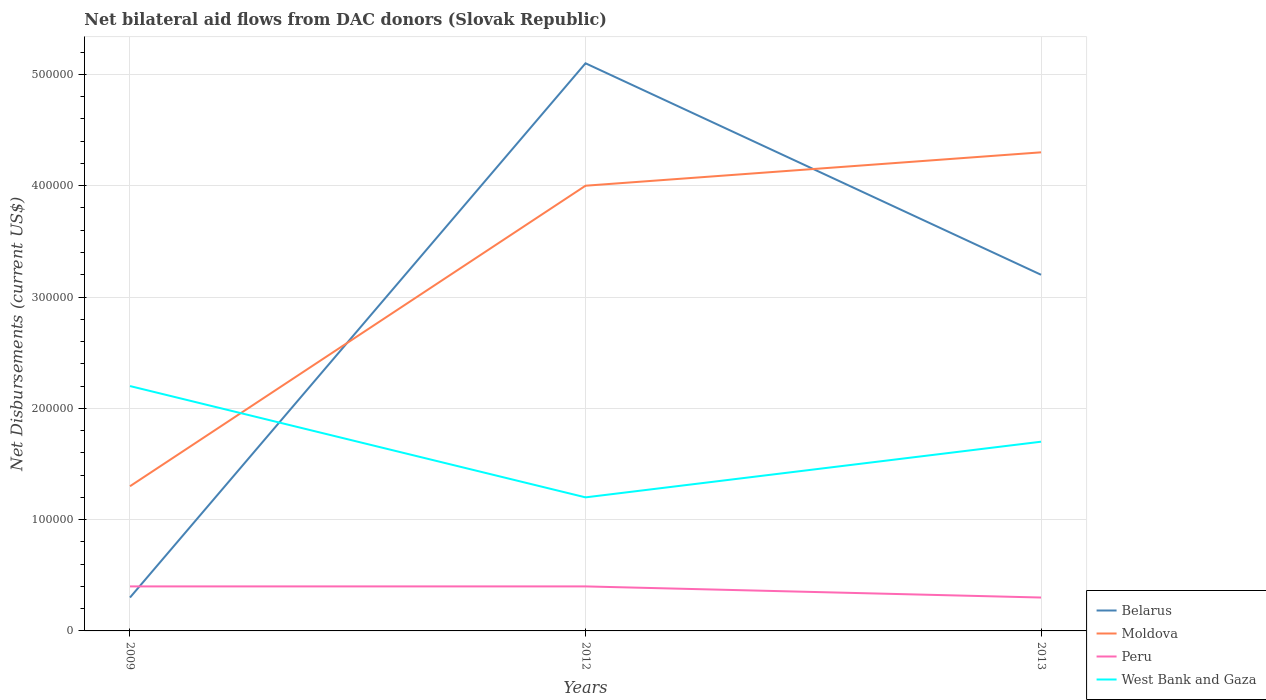How many different coloured lines are there?
Keep it short and to the point. 4. Across all years, what is the maximum net bilateral aid flows in Belarus?
Give a very brief answer. 3.00e+04. In which year was the net bilateral aid flows in Belarus maximum?
Provide a succinct answer. 2009. What is the total net bilateral aid flows in Peru in the graph?
Keep it short and to the point. 10000. What is the difference between the highest and the second highest net bilateral aid flows in West Bank and Gaza?
Provide a short and direct response. 1.00e+05. What is the difference between the highest and the lowest net bilateral aid flows in Belarus?
Give a very brief answer. 2. Is the net bilateral aid flows in Peru strictly greater than the net bilateral aid flows in Belarus over the years?
Your answer should be compact. No. How many years are there in the graph?
Offer a very short reply. 3. Does the graph contain any zero values?
Your answer should be compact. No. Does the graph contain grids?
Provide a succinct answer. Yes. Where does the legend appear in the graph?
Your response must be concise. Bottom right. How are the legend labels stacked?
Give a very brief answer. Vertical. What is the title of the graph?
Provide a short and direct response. Net bilateral aid flows from DAC donors (Slovak Republic). What is the label or title of the Y-axis?
Offer a terse response. Net Disbursements (current US$). What is the Net Disbursements (current US$) in Moldova in 2009?
Your response must be concise. 1.30e+05. What is the Net Disbursements (current US$) in Peru in 2009?
Your answer should be very brief. 4.00e+04. What is the Net Disbursements (current US$) of Belarus in 2012?
Make the answer very short. 5.10e+05. What is the Net Disbursements (current US$) in Peru in 2012?
Provide a short and direct response. 4.00e+04. What is the Net Disbursements (current US$) in Belarus in 2013?
Your response must be concise. 3.20e+05. Across all years, what is the maximum Net Disbursements (current US$) of Belarus?
Offer a terse response. 5.10e+05. Across all years, what is the maximum Net Disbursements (current US$) in Peru?
Keep it short and to the point. 4.00e+04. Across all years, what is the minimum Net Disbursements (current US$) in Moldova?
Offer a terse response. 1.30e+05. What is the total Net Disbursements (current US$) in Belarus in the graph?
Make the answer very short. 8.60e+05. What is the total Net Disbursements (current US$) in Moldova in the graph?
Your answer should be compact. 9.60e+05. What is the total Net Disbursements (current US$) in Peru in the graph?
Make the answer very short. 1.10e+05. What is the total Net Disbursements (current US$) of West Bank and Gaza in the graph?
Provide a succinct answer. 5.10e+05. What is the difference between the Net Disbursements (current US$) in Belarus in 2009 and that in 2012?
Your answer should be compact. -4.80e+05. What is the difference between the Net Disbursements (current US$) of Moldova in 2009 and that in 2012?
Give a very brief answer. -2.70e+05. What is the difference between the Net Disbursements (current US$) in Peru in 2009 and that in 2012?
Your answer should be compact. 0. What is the difference between the Net Disbursements (current US$) of Belarus in 2009 and that in 2013?
Provide a short and direct response. -2.90e+05. What is the difference between the Net Disbursements (current US$) in Moldova in 2009 and that in 2013?
Keep it short and to the point. -3.00e+05. What is the difference between the Net Disbursements (current US$) in Belarus in 2012 and that in 2013?
Your answer should be very brief. 1.90e+05. What is the difference between the Net Disbursements (current US$) of Belarus in 2009 and the Net Disbursements (current US$) of Moldova in 2012?
Your answer should be compact. -3.70e+05. What is the difference between the Net Disbursements (current US$) of Moldova in 2009 and the Net Disbursements (current US$) of Peru in 2012?
Your answer should be compact. 9.00e+04. What is the difference between the Net Disbursements (current US$) in Moldova in 2009 and the Net Disbursements (current US$) in West Bank and Gaza in 2012?
Give a very brief answer. 10000. What is the difference between the Net Disbursements (current US$) in Peru in 2009 and the Net Disbursements (current US$) in West Bank and Gaza in 2012?
Give a very brief answer. -8.00e+04. What is the difference between the Net Disbursements (current US$) of Belarus in 2009 and the Net Disbursements (current US$) of Moldova in 2013?
Your response must be concise. -4.00e+05. What is the difference between the Net Disbursements (current US$) of Belarus in 2009 and the Net Disbursements (current US$) of West Bank and Gaza in 2013?
Your response must be concise. -1.40e+05. What is the difference between the Net Disbursements (current US$) of Belarus in 2012 and the Net Disbursements (current US$) of Moldova in 2013?
Offer a very short reply. 8.00e+04. What is the difference between the Net Disbursements (current US$) of Belarus in 2012 and the Net Disbursements (current US$) of West Bank and Gaza in 2013?
Offer a terse response. 3.40e+05. What is the difference between the Net Disbursements (current US$) in Moldova in 2012 and the Net Disbursements (current US$) in Peru in 2013?
Give a very brief answer. 3.70e+05. What is the difference between the Net Disbursements (current US$) in Moldova in 2012 and the Net Disbursements (current US$) in West Bank and Gaza in 2013?
Ensure brevity in your answer.  2.30e+05. What is the average Net Disbursements (current US$) in Belarus per year?
Provide a short and direct response. 2.87e+05. What is the average Net Disbursements (current US$) in Peru per year?
Ensure brevity in your answer.  3.67e+04. In the year 2009, what is the difference between the Net Disbursements (current US$) of Belarus and Net Disbursements (current US$) of Peru?
Keep it short and to the point. -10000. In the year 2009, what is the difference between the Net Disbursements (current US$) of Belarus and Net Disbursements (current US$) of West Bank and Gaza?
Your answer should be compact. -1.90e+05. In the year 2009, what is the difference between the Net Disbursements (current US$) of Moldova and Net Disbursements (current US$) of Peru?
Ensure brevity in your answer.  9.00e+04. In the year 2012, what is the difference between the Net Disbursements (current US$) in Belarus and Net Disbursements (current US$) in Moldova?
Give a very brief answer. 1.10e+05. In the year 2012, what is the difference between the Net Disbursements (current US$) of Belarus and Net Disbursements (current US$) of Peru?
Your response must be concise. 4.70e+05. In the year 2012, what is the difference between the Net Disbursements (current US$) of Belarus and Net Disbursements (current US$) of West Bank and Gaza?
Keep it short and to the point. 3.90e+05. In the year 2013, what is the difference between the Net Disbursements (current US$) in Belarus and Net Disbursements (current US$) in Peru?
Offer a terse response. 2.90e+05. In the year 2013, what is the difference between the Net Disbursements (current US$) of Peru and Net Disbursements (current US$) of West Bank and Gaza?
Offer a very short reply. -1.40e+05. What is the ratio of the Net Disbursements (current US$) in Belarus in 2009 to that in 2012?
Offer a very short reply. 0.06. What is the ratio of the Net Disbursements (current US$) of Moldova in 2009 to that in 2012?
Make the answer very short. 0.33. What is the ratio of the Net Disbursements (current US$) in West Bank and Gaza in 2009 to that in 2012?
Provide a succinct answer. 1.83. What is the ratio of the Net Disbursements (current US$) in Belarus in 2009 to that in 2013?
Your answer should be very brief. 0.09. What is the ratio of the Net Disbursements (current US$) in Moldova in 2009 to that in 2013?
Offer a very short reply. 0.3. What is the ratio of the Net Disbursements (current US$) of West Bank and Gaza in 2009 to that in 2013?
Ensure brevity in your answer.  1.29. What is the ratio of the Net Disbursements (current US$) in Belarus in 2012 to that in 2013?
Your response must be concise. 1.59. What is the ratio of the Net Disbursements (current US$) in Moldova in 2012 to that in 2013?
Make the answer very short. 0.93. What is the ratio of the Net Disbursements (current US$) of West Bank and Gaza in 2012 to that in 2013?
Your response must be concise. 0.71. What is the difference between the highest and the second highest Net Disbursements (current US$) in Belarus?
Give a very brief answer. 1.90e+05. What is the difference between the highest and the second highest Net Disbursements (current US$) in Moldova?
Give a very brief answer. 3.00e+04. What is the difference between the highest and the second highest Net Disbursements (current US$) in Peru?
Ensure brevity in your answer.  0. What is the difference between the highest and the lowest Net Disbursements (current US$) of Belarus?
Make the answer very short. 4.80e+05. What is the difference between the highest and the lowest Net Disbursements (current US$) in Peru?
Keep it short and to the point. 10000. What is the difference between the highest and the lowest Net Disbursements (current US$) in West Bank and Gaza?
Offer a terse response. 1.00e+05. 